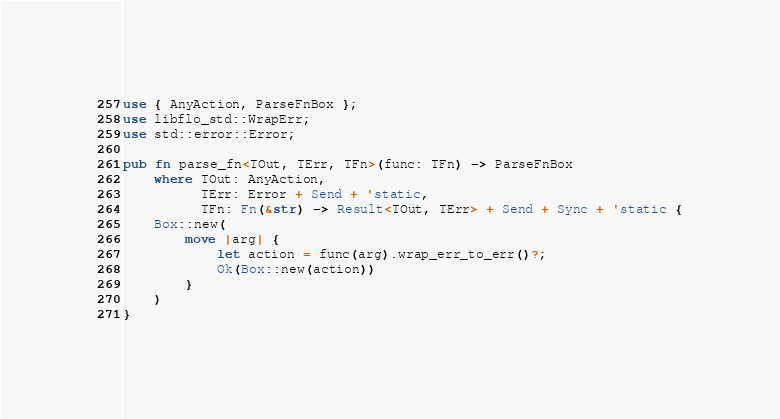<code> <loc_0><loc_0><loc_500><loc_500><_Rust_>use { AnyAction, ParseFnBox };
use libflo_std::WrapErr;
use std::error::Error;

pub fn parse_fn<TOut, TErr, TFn>(func: TFn) -> ParseFnBox
    where TOut: AnyAction,
          TErr: Error + Send + 'static,
          TFn: Fn(&str) -> Result<TOut, TErr> + Send + Sync + 'static {
    Box::new(
        move |arg| {
            let action = func(arg).wrap_err_to_err()?;
            Ok(Box::new(action))
        }
    )
}
</code> 